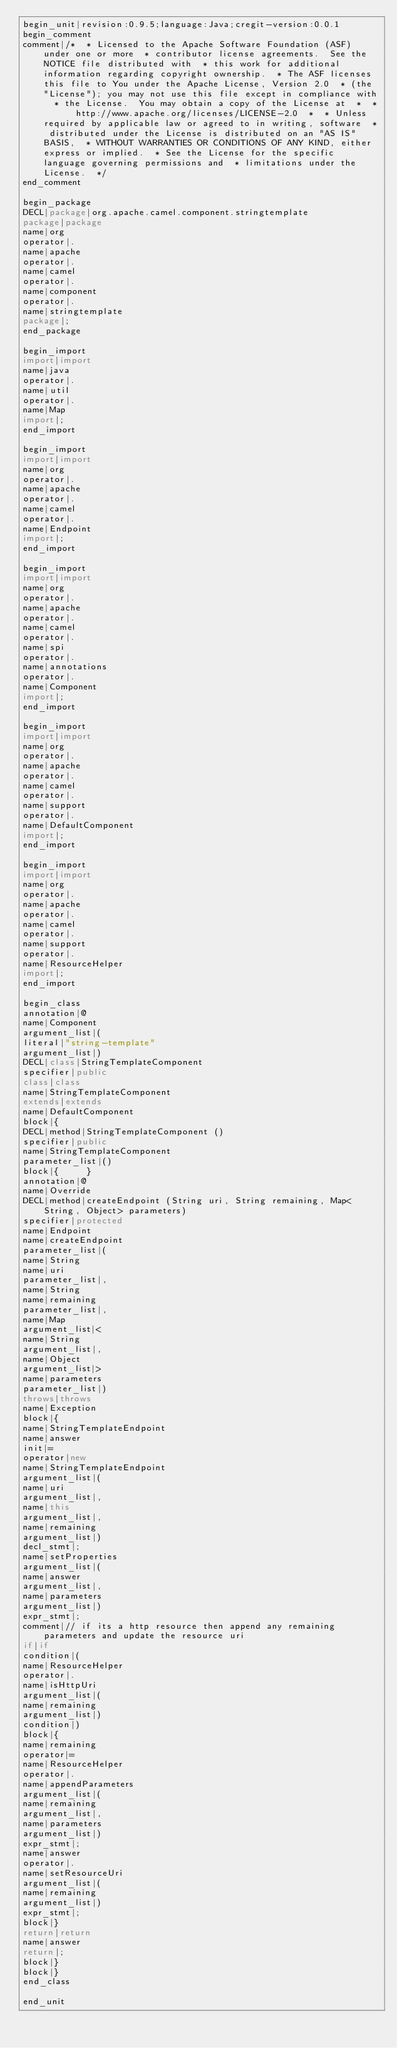Convert code to text. <code><loc_0><loc_0><loc_500><loc_500><_Java_>begin_unit|revision:0.9.5;language:Java;cregit-version:0.0.1
begin_comment
comment|/*  * Licensed to the Apache Software Foundation (ASF) under one or more  * contributor license agreements.  See the NOTICE file distributed with  * this work for additional information regarding copyright ownership.  * The ASF licenses this file to You under the Apache License, Version 2.0  * (the "License"); you may not use this file except in compliance with  * the License.  You may obtain a copy of the License at  *  *      http://www.apache.org/licenses/LICENSE-2.0  *  * Unless required by applicable law or agreed to in writing, software  * distributed under the License is distributed on an "AS IS" BASIS,  * WITHOUT WARRANTIES OR CONDITIONS OF ANY KIND, either express or implied.  * See the License for the specific language governing permissions and  * limitations under the License.  */
end_comment

begin_package
DECL|package|org.apache.camel.component.stringtemplate
package|package
name|org
operator|.
name|apache
operator|.
name|camel
operator|.
name|component
operator|.
name|stringtemplate
package|;
end_package

begin_import
import|import
name|java
operator|.
name|util
operator|.
name|Map
import|;
end_import

begin_import
import|import
name|org
operator|.
name|apache
operator|.
name|camel
operator|.
name|Endpoint
import|;
end_import

begin_import
import|import
name|org
operator|.
name|apache
operator|.
name|camel
operator|.
name|spi
operator|.
name|annotations
operator|.
name|Component
import|;
end_import

begin_import
import|import
name|org
operator|.
name|apache
operator|.
name|camel
operator|.
name|support
operator|.
name|DefaultComponent
import|;
end_import

begin_import
import|import
name|org
operator|.
name|apache
operator|.
name|camel
operator|.
name|support
operator|.
name|ResourceHelper
import|;
end_import

begin_class
annotation|@
name|Component
argument_list|(
literal|"string-template"
argument_list|)
DECL|class|StringTemplateComponent
specifier|public
class|class
name|StringTemplateComponent
extends|extends
name|DefaultComponent
block|{
DECL|method|StringTemplateComponent ()
specifier|public
name|StringTemplateComponent
parameter_list|()
block|{     }
annotation|@
name|Override
DECL|method|createEndpoint (String uri, String remaining, Map<String, Object> parameters)
specifier|protected
name|Endpoint
name|createEndpoint
parameter_list|(
name|String
name|uri
parameter_list|,
name|String
name|remaining
parameter_list|,
name|Map
argument_list|<
name|String
argument_list|,
name|Object
argument_list|>
name|parameters
parameter_list|)
throws|throws
name|Exception
block|{
name|StringTemplateEndpoint
name|answer
init|=
operator|new
name|StringTemplateEndpoint
argument_list|(
name|uri
argument_list|,
name|this
argument_list|,
name|remaining
argument_list|)
decl_stmt|;
name|setProperties
argument_list|(
name|answer
argument_list|,
name|parameters
argument_list|)
expr_stmt|;
comment|// if its a http resource then append any remaining parameters and update the resource uri
if|if
condition|(
name|ResourceHelper
operator|.
name|isHttpUri
argument_list|(
name|remaining
argument_list|)
condition|)
block|{
name|remaining
operator|=
name|ResourceHelper
operator|.
name|appendParameters
argument_list|(
name|remaining
argument_list|,
name|parameters
argument_list|)
expr_stmt|;
name|answer
operator|.
name|setResourceUri
argument_list|(
name|remaining
argument_list|)
expr_stmt|;
block|}
return|return
name|answer
return|;
block|}
block|}
end_class

end_unit

</code> 